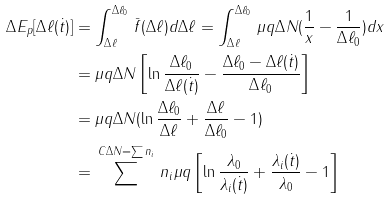<formula> <loc_0><loc_0><loc_500><loc_500>\Delta E _ { p } [ \Delta \ell ( \dot { t } ) ] & = \int _ { \Delta \ell } ^ { \Delta \ell _ { 0 } } \, \bar { f } ( \Delta \ell ) d \Delta \ell = \int _ { \Delta \ell } ^ { \Delta \ell _ { 0 } } \, \mu q \Delta N ( \frac { 1 } { x } - \frac { 1 } { \Delta \ell _ { 0 } } ) d x \\ & = \mu q \Delta N \left [ \ln \frac { \Delta \ell _ { 0 } } { \Delta \ell ( \dot { t } ) } - \frac { \Delta \ell _ { 0 } - \Delta \ell ( \dot { t } ) } { \Delta \ell _ { 0 } } \right ] \\ & = \mu q \Delta N ( \ln \frac { \Delta \ell _ { 0 } } { \Delta \ell } + \frac { \Delta \ell } { \Delta \ell _ { 0 } } - 1 ) \\ & = \, \sum ^ { C { \Delta N = \sum n _ { i } } } \, n _ { i } \mu q \left [ \ln \frac { \lambda _ { 0 } } { \lambda _ { i } ( \dot { t } ) } + \frac { \lambda _ { i } ( \dot { t } ) } { \lambda _ { 0 } } - 1 \right ]</formula> 